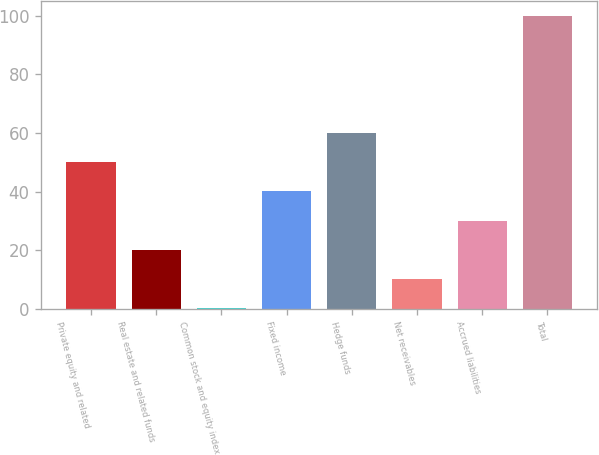Convert chart to OTSL. <chart><loc_0><loc_0><loc_500><loc_500><bar_chart><fcel>Private equity and related<fcel>Real estate and related funds<fcel>Common stock and equity index<fcel>Fixed income<fcel>Hedge funds<fcel>Net receivables<fcel>Accrued liabilities<fcel>Total<nl><fcel>50.1<fcel>20.16<fcel>0.2<fcel>40.12<fcel>60.08<fcel>10.18<fcel>30.14<fcel>100<nl></chart> 